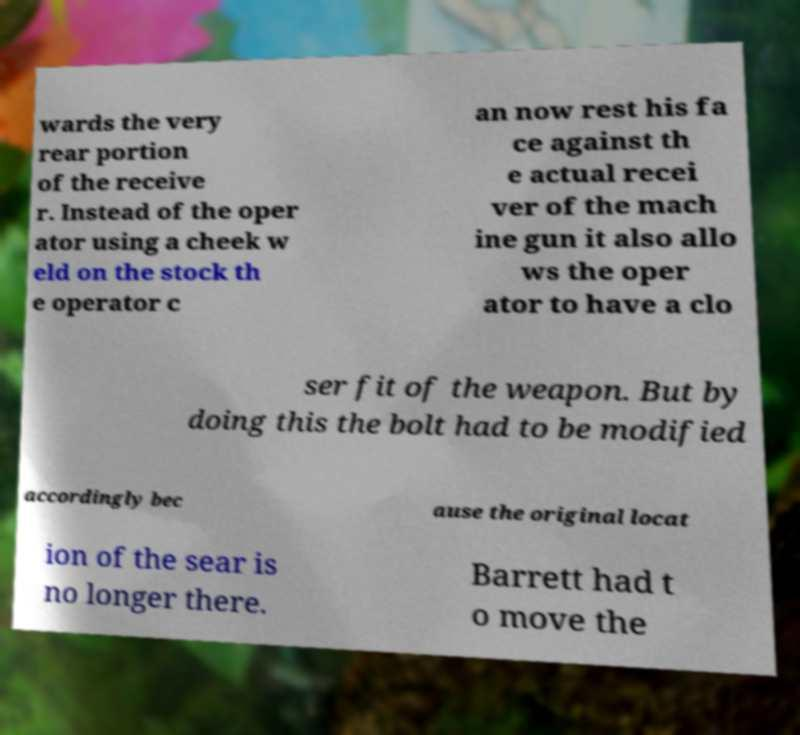Can you accurately transcribe the text from the provided image for me? wards the very rear portion of the receive r. Instead of the oper ator using a cheek w eld on the stock th e operator c an now rest his fa ce against th e actual recei ver of the mach ine gun it also allo ws the oper ator to have a clo ser fit of the weapon. But by doing this the bolt had to be modified accordingly bec ause the original locat ion of the sear is no longer there. Barrett had t o move the 